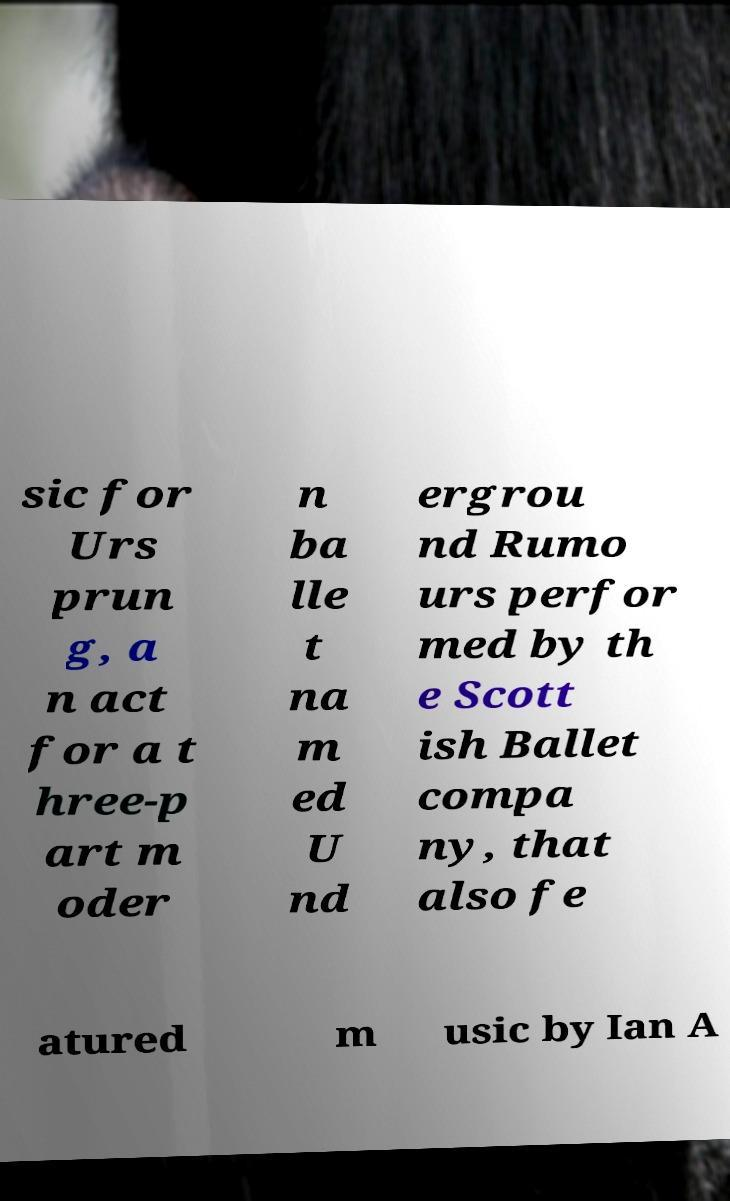I need the written content from this picture converted into text. Can you do that? sic for Urs prun g, a n act for a t hree-p art m oder n ba lle t na m ed U nd ergrou nd Rumo urs perfor med by th e Scott ish Ballet compa ny, that also fe atured m usic by Ian A 